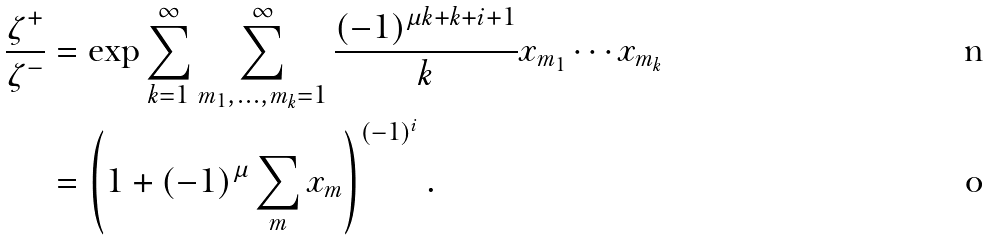<formula> <loc_0><loc_0><loc_500><loc_500>\frac { \zeta ^ { + } } { \zeta ^ { - } } & = \exp \sum _ { k = 1 } ^ { \infty } \sum _ { m _ { 1 } , \dots , m _ { k } = 1 } ^ { \infty } \frac { ( - 1 ) ^ { \mu k + k + i + 1 } } { k } x _ { m _ { 1 } } \cdots x _ { m _ { k } } \\ & = \left ( 1 + ( - 1 ) ^ { \mu } \sum _ { m } x _ { m } \right ) ^ { ( - 1 ) ^ { i } } .</formula> 